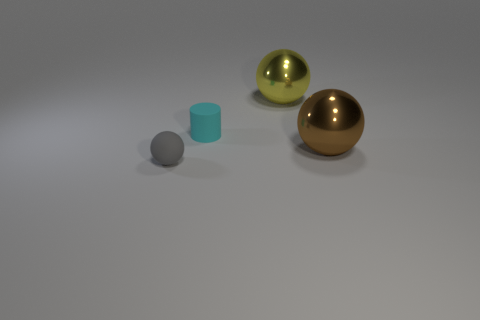There is a large ball behind the shiny thing that is in front of the yellow sphere; are there any cyan matte things that are left of it?
Make the answer very short. Yes. What is the color of the object that is made of the same material as the tiny cyan cylinder?
Your answer should be compact. Gray. There is a object that is both on the left side of the yellow shiny object and on the right side of the small gray matte object; how big is it?
Your answer should be very brief. Small. Is the number of spheres that are to the left of the small rubber sphere less than the number of rubber spheres that are left of the cyan cylinder?
Offer a very short reply. Yes. Is the large object that is behind the cyan thing made of the same material as the thing in front of the brown object?
Your answer should be very brief. No. The thing that is both behind the gray ball and on the left side of the yellow metallic object has what shape?
Make the answer very short. Cylinder. There is a large object in front of the large sphere behind the cyan rubber object; what is its material?
Your answer should be very brief. Metal. Is the number of blue metallic cylinders greater than the number of yellow spheres?
Provide a succinct answer. No. Do the tiny cylinder and the matte ball have the same color?
Provide a short and direct response. No. There is a cyan cylinder that is the same size as the matte sphere; what material is it?
Offer a very short reply. Rubber. 